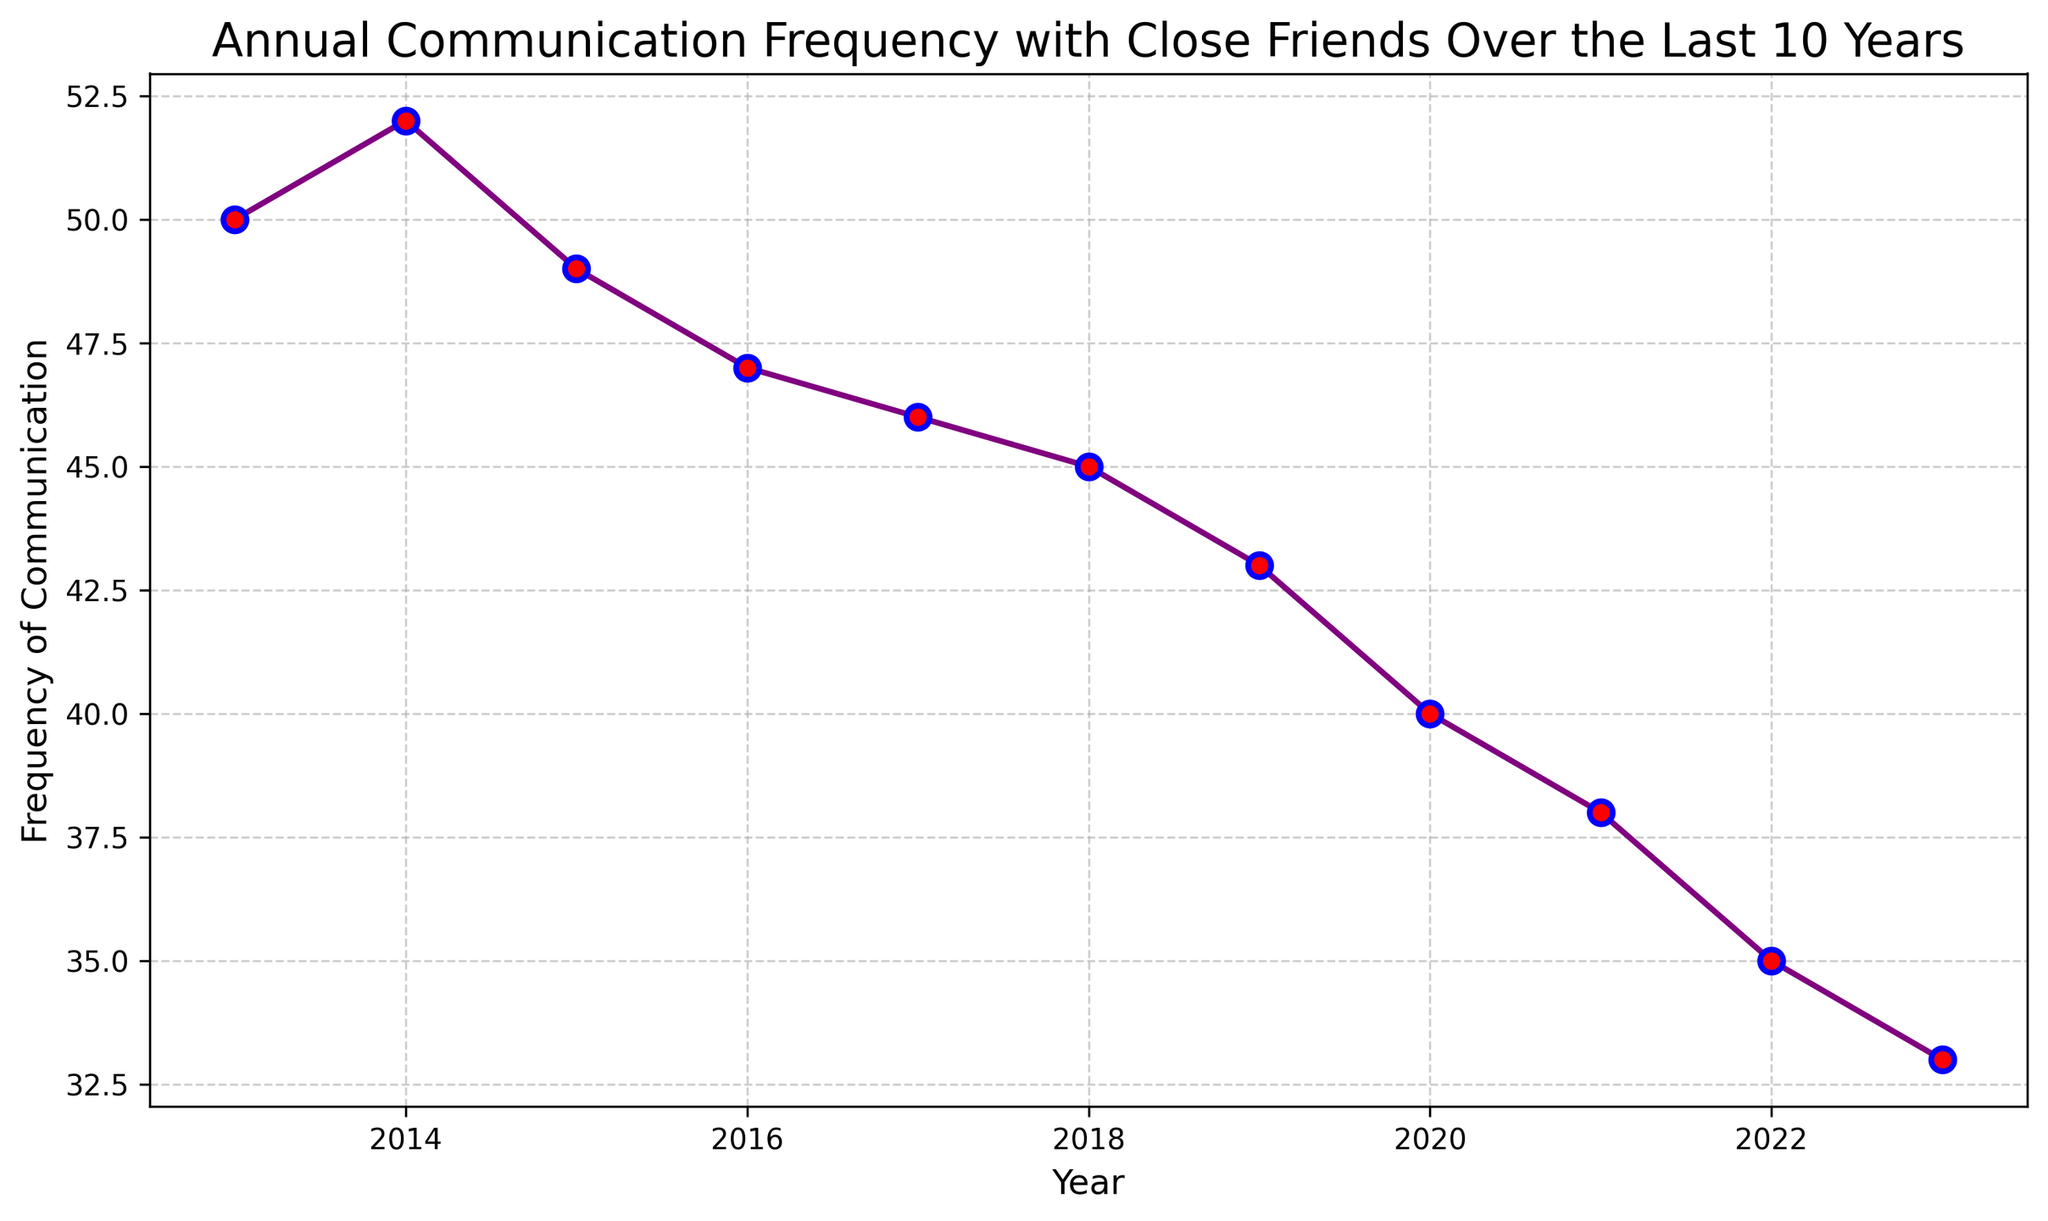What's the highest frequency of communication and in what year was it recorded? The highest frequency of communication can be identified by looking for the tallest (peak) point on the line chart. The peak appears to be in 2014 with a frequency of 52.
Answer: 52, in 2014 How much did the communication frequency drop from 2013 to 2023? To find the drop in frequency, subtract the 2023 value from the 2013 value. The frequency in 2013 was 50, and in 2023 it was 33. Therefore, the drop is 50 - 33 = 17.
Answer: 17 In which year did the frequency first drop below 40? To find the first year where the frequency dropped below 40, examine the data points and look for the first instance below the value of 40. The frequency first dropped below 40 in 2021.
Answer: 2021 What is the average communication frequency over the 10 years? To calculate the average, sum all annual frequencies and divide by the number of years. (50 + 52 + 49 + 47 + 46 + 45 + 43 + 40 + 38 + 35 + 33)/11 = 428/11 ≈ 38.91.
Answer: 38.91 Which year had the smallest drop in frequency compared to the previous year? To determine this, calculate the differences between each year and the one before it. The smallest drop occurs between 2013 and 2014 (52 - 50 = 2).
Answer: 2014 During which 5-year period was the communication frequency most stable (with the smallest overall change)? Calculate the overall change over each 5-year period: 
- 2013-2017: 46 - 50 = -4
- 2014-2018: 45 - 52 = -7
- 2015-2019: 43 - 49 = -6
- 2016-2020: 40 - 47 = -7
- 2017-2021: 38 - 46 = -8
The change is smallest (4) during the period 2013-2017.
Answer: 2013-2017 Identify two consecutive years where the decline in communication frequency was the greatest. To find this, calculate the drop between each consecutive year. The largest drop is between 2014 and 2015 (52 - 49 = 3) and between 2021 to 2022 (38 - 35 = 3). Thus, these two periods are tied.
Answer: 2014 to 2015, and 2021 to 2022 